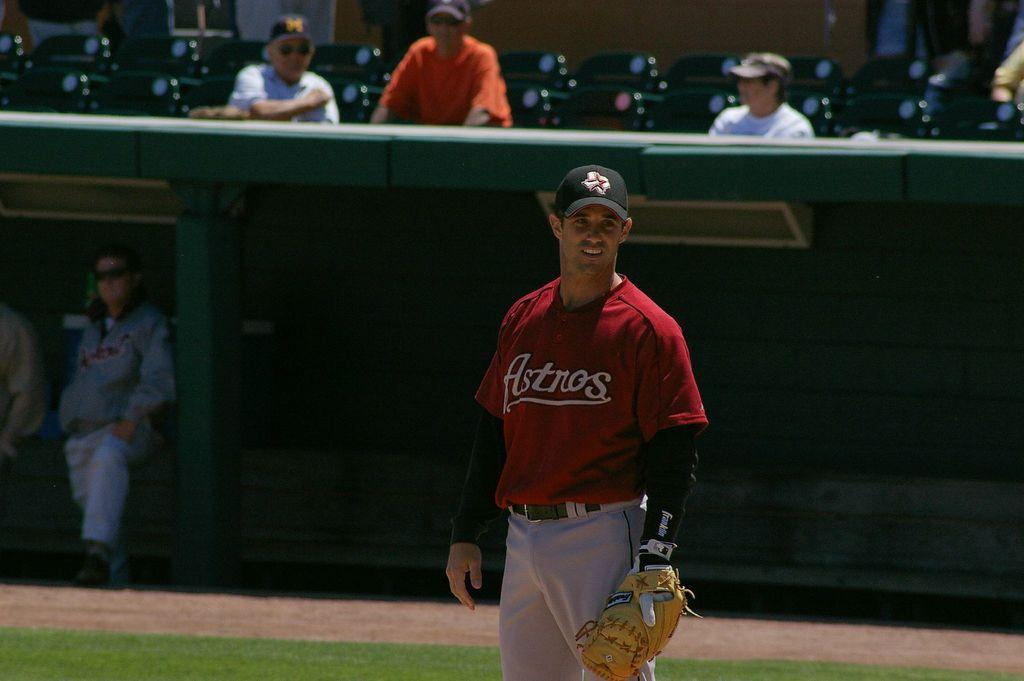Provide a one-sentence caption for the provided image. An Astros baseball player is on the field. 